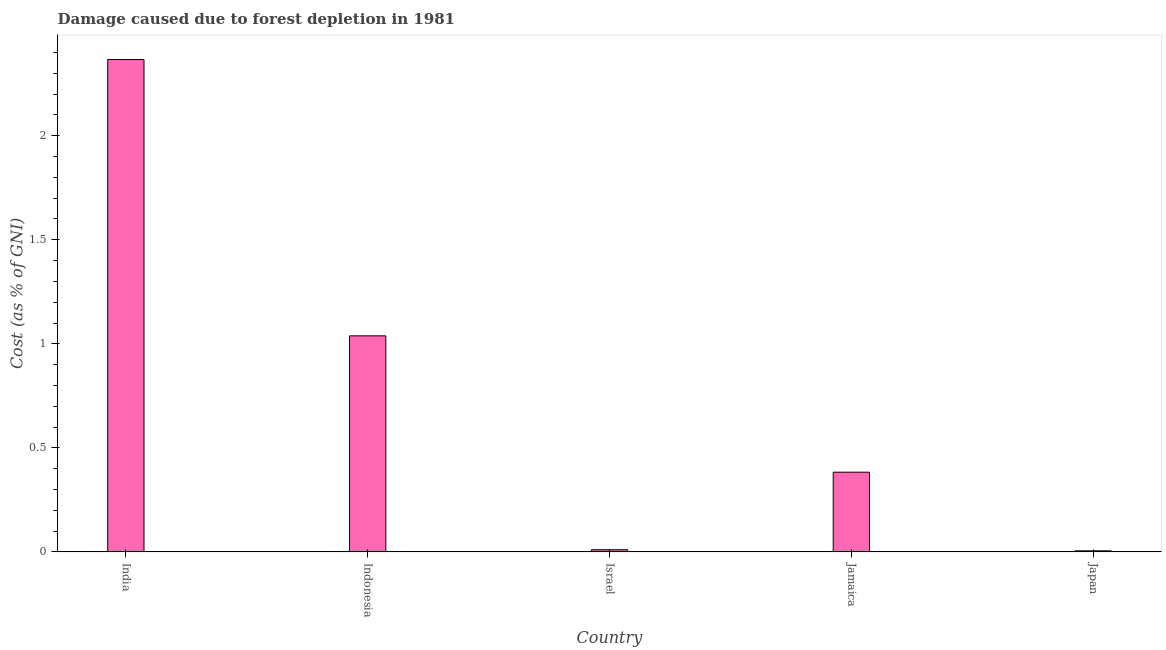What is the title of the graph?
Give a very brief answer. Damage caused due to forest depletion in 1981. What is the label or title of the Y-axis?
Make the answer very short. Cost (as % of GNI). What is the damage caused due to forest depletion in Jamaica?
Your answer should be very brief. 0.38. Across all countries, what is the maximum damage caused due to forest depletion?
Provide a succinct answer. 2.37. Across all countries, what is the minimum damage caused due to forest depletion?
Offer a very short reply. 0.01. In which country was the damage caused due to forest depletion maximum?
Give a very brief answer. India. In which country was the damage caused due to forest depletion minimum?
Offer a very short reply. Japan. What is the sum of the damage caused due to forest depletion?
Offer a very short reply. 3.8. What is the difference between the damage caused due to forest depletion in India and Jamaica?
Provide a succinct answer. 1.98. What is the average damage caused due to forest depletion per country?
Offer a very short reply. 0.76. What is the median damage caused due to forest depletion?
Your response must be concise. 0.38. In how many countries, is the damage caused due to forest depletion greater than 1.8 %?
Provide a succinct answer. 1. What is the ratio of the damage caused due to forest depletion in India to that in Israel?
Your response must be concise. 232.52. Is the damage caused due to forest depletion in Indonesia less than that in Japan?
Your answer should be very brief. No. What is the difference between the highest and the second highest damage caused due to forest depletion?
Provide a short and direct response. 1.33. What is the difference between the highest and the lowest damage caused due to forest depletion?
Ensure brevity in your answer.  2.36. In how many countries, is the damage caused due to forest depletion greater than the average damage caused due to forest depletion taken over all countries?
Your answer should be very brief. 2. How many bars are there?
Provide a succinct answer. 5. Are all the bars in the graph horizontal?
Keep it short and to the point. No. What is the difference between two consecutive major ticks on the Y-axis?
Provide a succinct answer. 0.5. Are the values on the major ticks of Y-axis written in scientific E-notation?
Provide a short and direct response. No. What is the Cost (as % of GNI) of India?
Ensure brevity in your answer.  2.37. What is the Cost (as % of GNI) in Indonesia?
Your answer should be very brief. 1.04. What is the Cost (as % of GNI) of Israel?
Keep it short and to the point. 0.01. What is the Cost (as % of GNI) in Jamaica?
Give a very brief answer. 0.38. What is the Cost (as % of GNI) in Japan?
Give a very brief answer. 0.01. What is the difference between the Cost (as % of GNI) in India and Indonesia?
Provide a succinct answer. 1.33. What is the difference between the Cost (as % of GNI) in India and Israel?
Ensure brevity in your answer.  2.36. What is the difference between the Cost (as % of GNI) in India and Jamaica?
Your answer should be very brief. 1.98. What is the difference between the Cost (as % of GNI) in India and Japan?
Make the answer very short. 2.36. What is the difference between the Cost (as % of GNI) in Indonesia and Israel?
Make the answer very short. 1.03. What is the difference between the Cost (as % of GNI) in Indonesia and Jamaica?
Give a very brief answer. 0.66. What is the difference between the Cost (as % of GNI) in Indonesia and Japan?
Offer a terse response. 1.03. What is the difference between the Cost (as % of GNI) in Israel and Jamaica?
Make the answer very short. -0.37. What is the difference between the Cost (as % of GNI) in Israel and Japan?
Your answer should be very brief. 0.01. What is the difference between the Cost (as % of GNI) in Jamaica and Japan?
Your answer should be compact. 0.38. What is the ratio of the Cost (as % of GNI) in India to that in Indonesia?
Your answer should be very brief. 2.28. What is the ratio of the Cost (as % of GNI) in India to that in Israel?
Provide a short and direct response. 232.52. What is the ratio of the Cost (as % of GNI) in India to that in Jamaica?
Provide a short and direct response. 6.18. What is the ratio of the Cost (as % of GNI) in India to that in Japan?
Offer a terse response. 473.32. What is the ratio of the Cost (as % of GNI) in Indonesia to that in Israel?
Provide a short and direct response. 102.02. What is the ratio of the Cost (as % of GNI) in Indonesia to that in Jamaica?
Your response must be concise. 2.71. What is the ratio of the Cost (as % of GNI) in Indonesia to that in Japan?
Provide a succinct answer. 207.66. What is the ratio of the Cost (as % of GNI) in Israel to that in Jamaica?
Give a very brief answer. 0.03. What is the ratio of the Cost (as % of GNI) in Israel to that in Japan?
Ensure brevity in your answer.  2.04. What is the ratio of the Cost (as % of GNI) in Jamaica to that in Japan?
Keep it short and to the point. 76.59. 